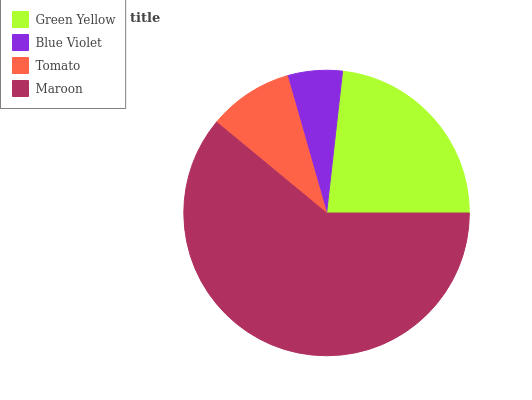Is Blue Violet the minimum?
Answer yes or no. Yes. Is Maroon the maximum?
Answer yes or no. Yes. Is Tomato the minimum?
Answer yes or no. No. Is Tomato the maximum?
Answer yes or no. No. Is Tomato greater than Blue Violet?
Answer yes or no. Yes. Is Blue Violet less than Tomato?
Answer yes or no. Yes. Is Blue Violet greater than Tomato?
Answer yes or no. No. Is Tomato less than Blue Violet?
Answer yes or no. No. Is Green Yellow the high median?
Answer yes or no. Yes. Is Tomato the low median?
Answer yes or no. Yes. Is Blue Violet the high median?
Answer yes or no. No. Is Maroon the low median?
Answer yes or no. No. 